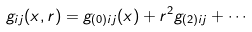<formula> <loc_0><loc_0><loc_500><loc_500>g _ { i j } ( x , r ) = g _ { ( 0 ) i j } ( x ) + r ^ { 2 } g _ { ( 2 ) i j } + \cdots</formula> 